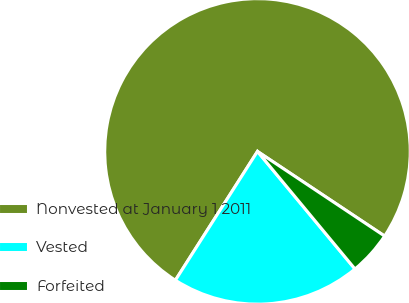Convert chart. <chart><loc_0><loc_0><loc_500><loc_500><pie_chart><fcel>Nonvested at January 1 2011<fcel>Vested<fcel>Forfeited<nl><fcel>75.32%<fcel>20.05%<fcel>4.63%<nl></chart> 